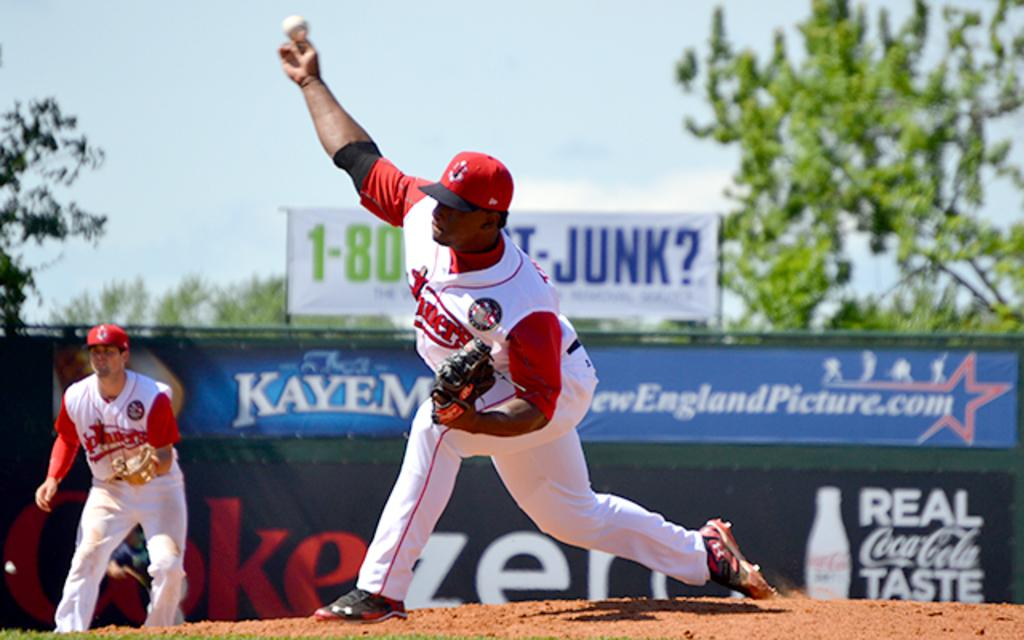<image>
Provide a brief description of the given image. Pitcher throws the ball from the pitcher's mound in front of an ad for Coca-Cola. 